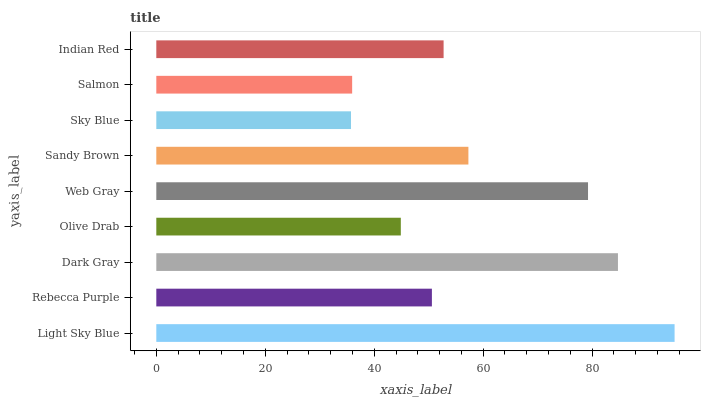Is Sky Blue the minimum?
Answer yes or no. Yes. Is Light Sky Blue the maximum?
Answer yes or no. Yes. Is Rebecca Purple the minimum?
Answer yes or no. No. Is Rebecca Purple the maximum?
Answer yes or no. No. Is Light Sky Blue greater than Rebecca Purple?
Answer yes or no. Yes. Is Rebecca Purple less than Light Sky Blue?
Answer yes or no. Yes. Is Rebecca Purple greater than Light Sky Blue?
Answer yes or no. No. Is Light Sky Blue less than Rebecca Purple?
Answer yes or no. No. Is Indian Red the high median?
Answer yes or no. Yes. Is Indian Red the low median?
Answer yes or no. Yes. Is Web Gray the high median?
Answer yes or no. No. Is Web Gray the low median?
Answer yes or no. No. 